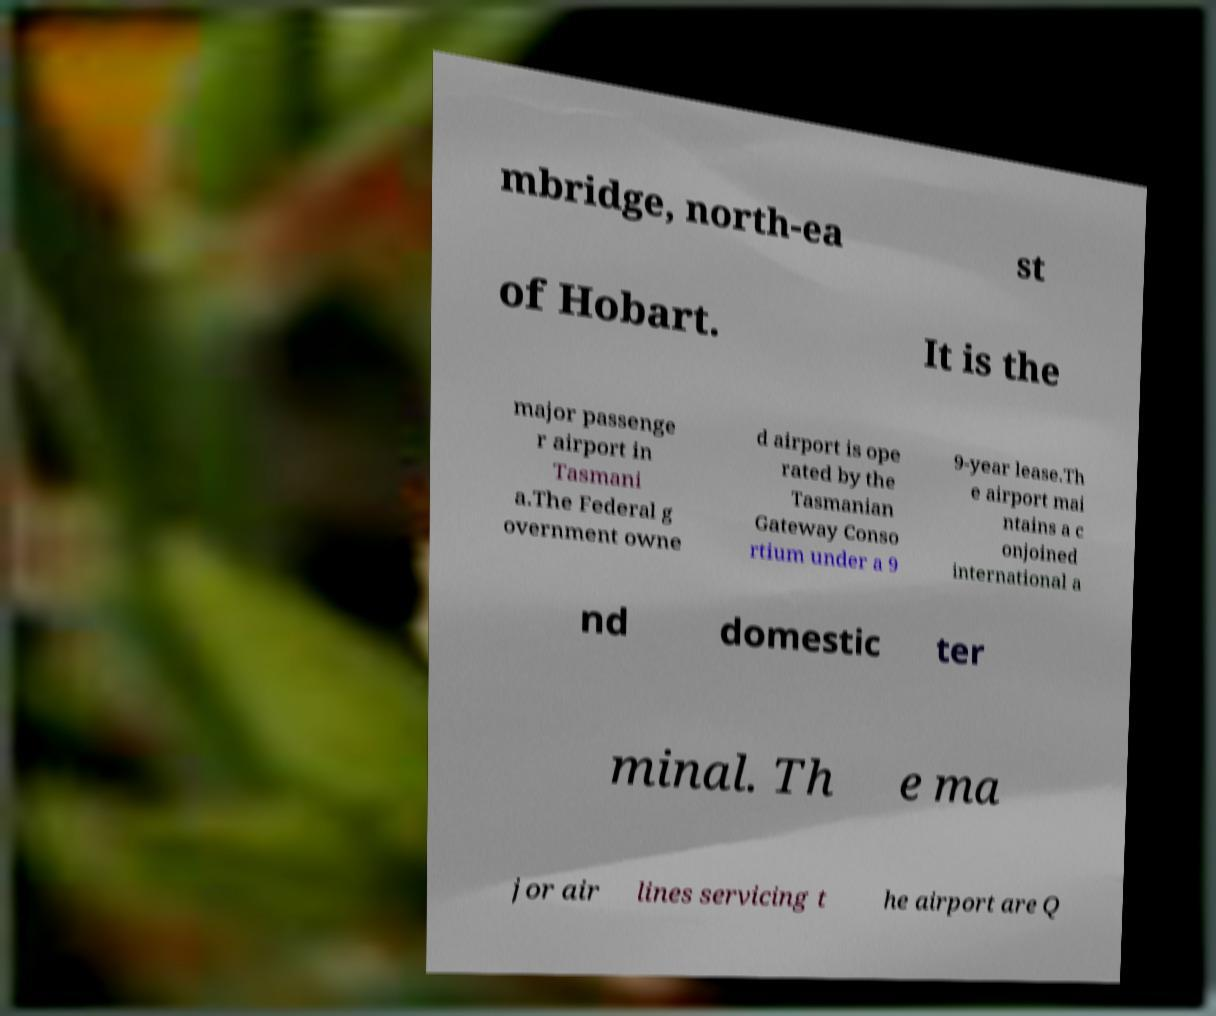Can you read and provide the text displayed in the image?This photo seems to have some interesting text. Can you extract and type it out for me? mbridge, north-ea st of Hobart. It is the major passenge r airport in Tasmani a.The Federal g overnment owne d airport is ope rated by the Tasmanian Gateway Conso rtium under a 9 9-year lease.Th e airport mai ntains a c onjoined international a nd domestic ter minal. Th e ma jor air lines servicing t he airport are Q 